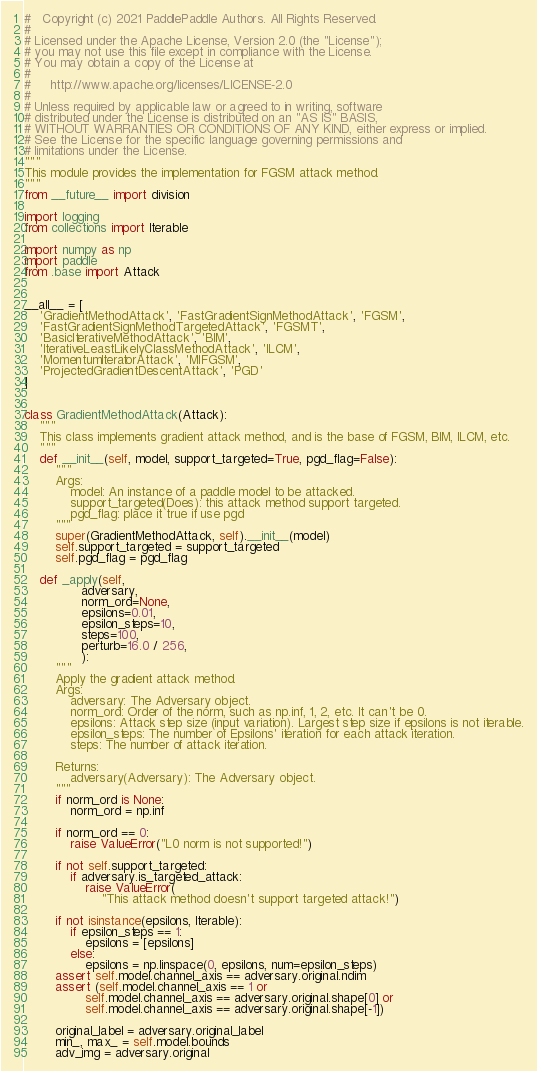Convert code to text. <code><loc_0><loc_0><loc_500><loc_500><_Python_>#   Copyright (c) 2021 PaddlePaddle Authors. All Rights Reserved.
#
# Licensed under the Apache License, Version 2.0 (the "License");
# you may not use this file except in compliance with the License.
# You may obtain a copy of the License at
#
#     http://www.apache.org/licenses/LICENSE-2.0
#
# Unless required by applicable law or agreed to in writing, software
# distributed under the License is distributed on an "AS IS" BASIS,
# WITHOUT WARRANTIES OR CONDITIONS OF ANY KIND, either express or implied.
# See the License for the specific language governing permissions and
# limitations under the License.
"""
This module provides the implementation for FGSM attack method.
"""
from __future__ import division

import logging
from collections import Iterable

import numpy as np
import paddle
from .base import Attack


__all__ = [
    'GradientMethodAttack', 'FastGradientSignMethodAttack', 'FGSM',
    'FastGradientSignMethodTargetedAttack', 'FGSMT',
    'BasicIterativeMethodAttack', 'BIM',
    'IterativeLeastLikelyClassMethodAttack', 'ILCM',
    'MomentumIteratorAttack', 'MIFGSM',
    'ProjectedGradientDescentAttack', 'PGD'
]


class GradientMethodAttack(Attack):
    """
    This class implements gradient attack method, and is the base of FGSM, BIM, ILCM, etc.
    """
    def __init__(self, model, support_targeted=True, pgd_flag=False):
        """
        Args:
            model: An instance of a paddle model to be attacked.
            support_targeted(Does): this attack method support targeted.
            pgd_flag: place it true if use pgd
        """
        super(GradientMethodAttack, self).__init__(model)
        self.support_targeted = support_targeted
        self.pgd_flag = pgd_flag

    def _apply(self,
               adversary,
               norm_ord=None,
               epsilons=0.01,
               epsilon_steps=10,
               steps=100,
               perturb=16.0 / 256,
               ):
        """
        Apply the gradient attack method.
        Args:
            adversary: The Adversary object.
            norm_ord: Order of the norm, such as np.inf, 1, 2, etc. It can't be 0.
            epsilons: Attack step size (input variation). Largest step size if epsilons is not iterable.
            epsilon_steps: The number of Epsilons' iteration for each attack iteration.
            steps: The number of attack iteration.

        Returns:
            adversary(Adversary): The Adversary object.
        """
        if norm_ord is None:
            norm_ord = np.inf

        if norm_ord == 0:
            raise ValueError("L0 norm is not supported!")

        if not self.support_targeted:
            if adversary.is_targeted_attack:
                raise ValueError(
                    "This attack method doesn't support targeted attack!")

        if not isinstance(epsilons, Iterable):
            if epsilon_steps == 1:
                epsilons = [epsilons]
            else:
                epsilons = np.linspace(0, epsilons, num=epsilon_steps)
        assert self.model.channel_axis == adversary.original.ndim
        assert (self.model.channel_axis == 1 or
                self.model.channel_axis == adversary.original.shape[0] or
                self.model.channel_axis == adversary.original.shape[-1])

        original_label = adversary.original_label
        min_, max_ = self.model.bounds
        adv_img = adversary.original</code> 